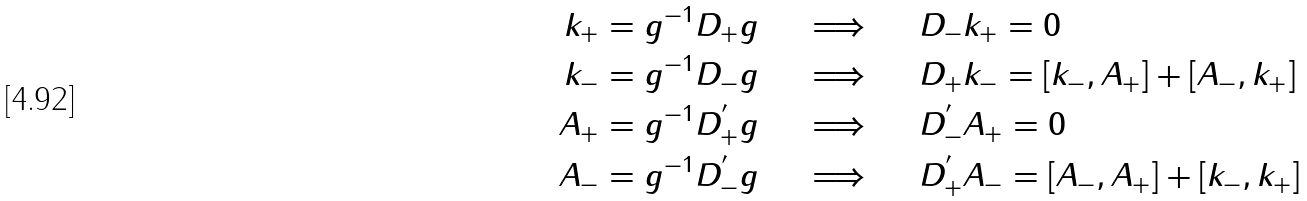<formula> <loc_0><loc_0><loc_500><loc_500>k _ { + } & = g ^ { - 1 } D _ { + } g \quad \ \Longrightarrow \quad \ D _ { - } k _ { + } = 0 \\ k _ { - } & = g ^ { - 1 } D _ { - } g \quad \ \Longrightarrow \quad \ D _ { + } k _ { - } = [ k _ { - } , A _ { + } ] + [ A _ { - } , k _ { + } ] \\ A _ { + } & = g ^ { - 1 } D _ { + } ^ { ^ { \prime } } g \quad \ \Longrightarrow \quad \ D _ { - } ^ { ^ { \prime } } A _ { + } = 0 \\ A _ { - } & = g ^ { - 1 } D _ { - } ^ { ^ { \prime } } g \quad \ \Longrightarrow \quad \ D _ { + } ^ { ^ { \prime } } A _ { - } = [ A _ { - } , A _ { + } ] + [ k _ { - } , k _ { + } ]</formula> 